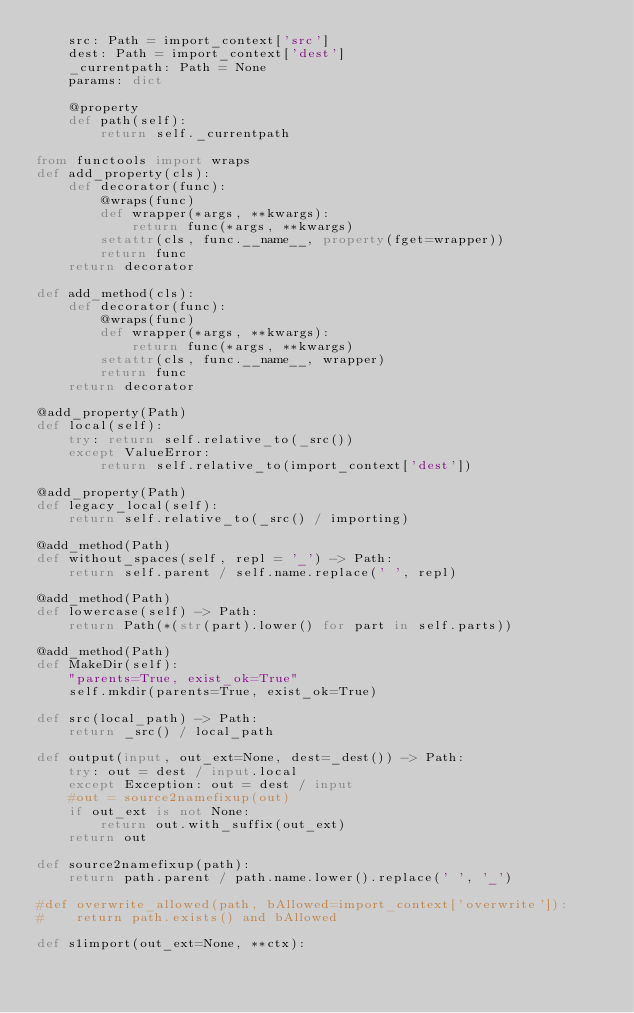<code> <loc_0><loc_0><loc_500><loc_500><_Python_>    src: Path = import_context['src']
    dest: Path = import_context['dest']
    _currentpath: Path = None
    params: dict

    @property
    def path(self):
        return self._currentpath

from functools import wraps
def add_property(cls):
    def decorator(func):
        @wraps(func)
        def wrapper(*args, **kwargs):
            return func(*args, **kwargs)
        setattr(cls, func.__name__, property(fget=wrapper))
        return func
    return decorator

def add_method(cls):
    def decorator(func):
        @wraps(func)
        def wrapper(*args, **kwargs):
            return func(*args, **kwargs)
        setattr(cls, func.__name__, wrapper)
        return func
    return decorator

@add_property(Path)
def local(self):
    try: return self.relative_to(_src())
    except ValueError:
        return self.relative_to(import_context['dest'])

@add_property(Path)
def legacy_local(self):
    return self.relative_to(_src() / importing)

@add_method(Path)
def without_spaces(self, repl = '_') -> Path:
    return self.parent / self.name.replace(' ', repl)

@add_method(Path)
def lowercase(self) -> Path:
    return Path(*(str(part).lower() for part in self.parts))

@add_method(Path)
def MakeDir(self):
    "parents=True, exist_ok=True"
    self.mkdir(parents=True, exist_ok=True)

def src(local_path) -> Path:
    return _src() / local_path

def output(input, out_ext=None, dest=_dest()) -> Path:
    try: out = dest / input.local
    except Exception: out = dest / input
    #out = source2namefixup(out)
    if out_ext is not None:
        return out.with_suffix(out_ext)
    return out

def source2namefixup(path):
    return path.parent / path.name.lower().replace(' ', '_')

#def overwrite_allowed(path, bAllowed=import_context['overwrite']):
#    return path.exists() and bAllowed

def s1import(out_ext=None, **ctx):</code> 